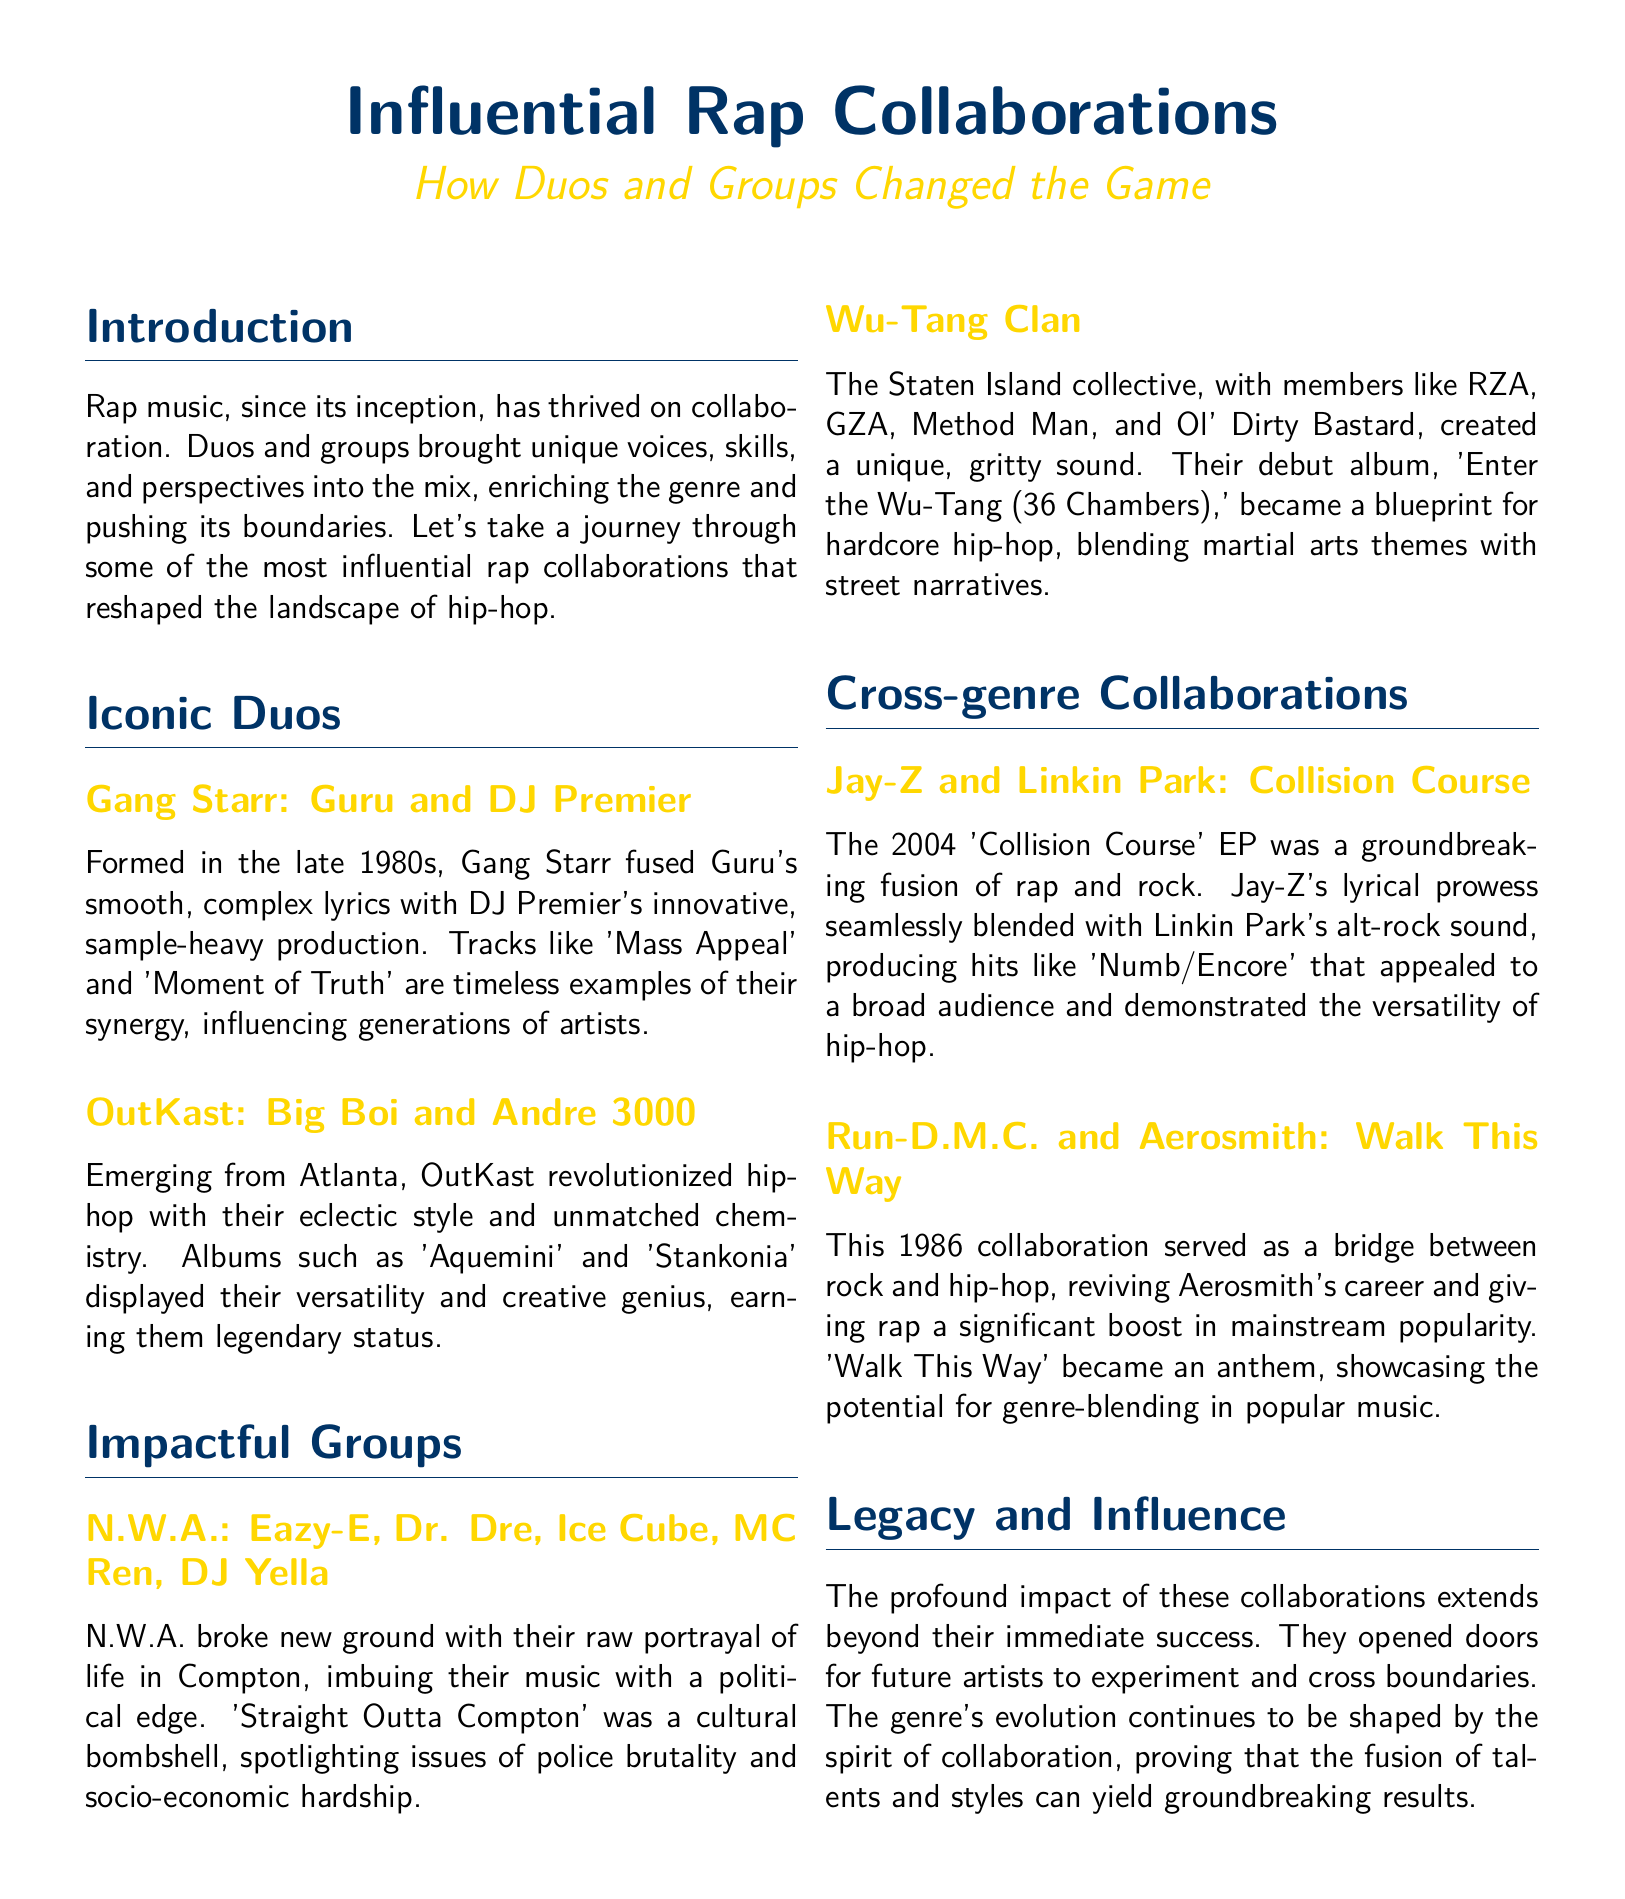What are the names of the members in Gang Starr? The document lists Guru and DJ Premier as the members of Gang Starr.
Answer: Guru and DJ Premier Which album by OutKast is mentioned in the document? The document specifically mentions the albums 'Aquemini' and 'Stankonia' by OutKast.
Answer: Aquemini, Stankonia What year was the 'Collision Course' EP released? The document states that the 'Collision Course' EP was released in 2004.
Answer: 2004 What city is associated with N.W.A.? The document identifies Compton as the city related to N.W.A.
Answer: Compton What is the title of Wu-Tang Clan's debut album? The document states that their debut album is 'Enter the Wu-Tang (36 Chambers)'.
Answer: Enter the Wu-Tang (36 Chambers) What genre did Run-D.M.C. and Aerosmith blend in their collaboration? The document indicates that Run-D.M.C. and Aerosmith fused rock and hip-hop.
Answer: Rock and hip-hop How did collaborations influence the future of rap music? The document suggests that collaborations opened doors for future artists to experiment and cross boundaries.
Answer: Experimentation and boundary-crossing What is a significant theme found in Wu-Tang Clan's music? The document mentions that Wu-Tang Clan's music blends martial arts themes with street narratives.
Answer: Martial arts themes What style did Gang Starr contribute to rap music? The document states that Gang Starr fused smooth, complex lyrics and innovative, sample-heavy production.
Answer: Smooth, complex lyrics and innovative, sample-heavy production 